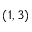Convert formula to latex. <formula><loc_0><loc_0><loc_500><loc_500>( 1 , 3 )</formula> 